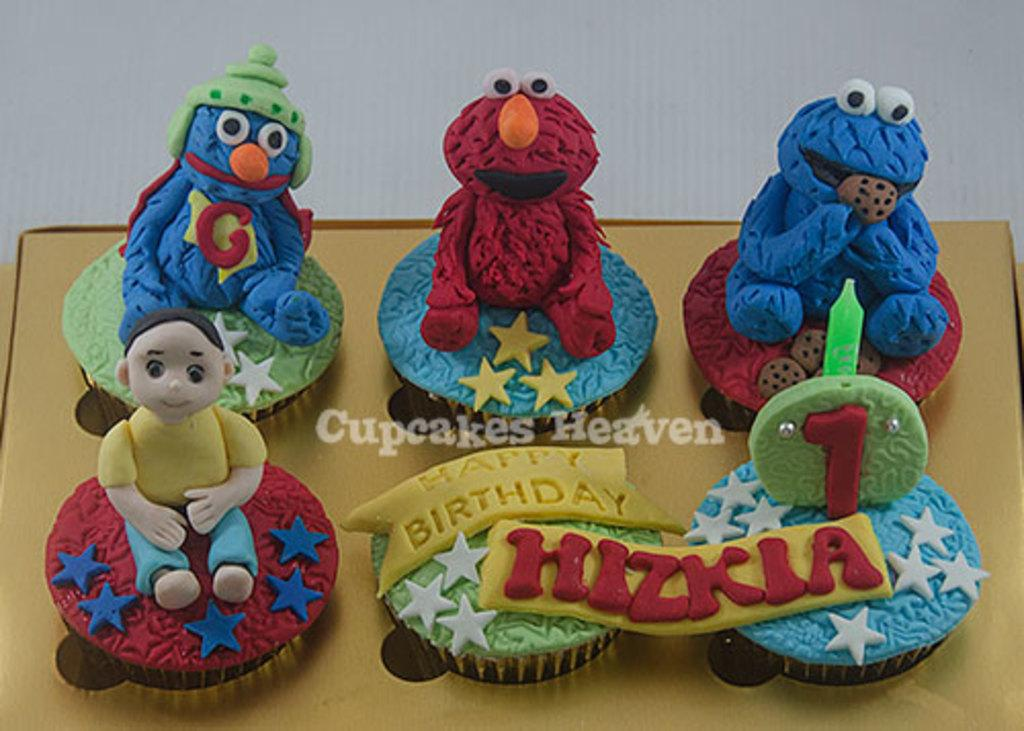What type of food can be seen in the image? There are cupcakes in the image. What color is the background of the image? The background of the image is white. Is there any text or logo visible in the image? Yes, there is a watermark in the center of the image. How many chairs are visible in the image? There are no chairs present in the image. Is there any poison visible in the image? There is no poison present in the image. 